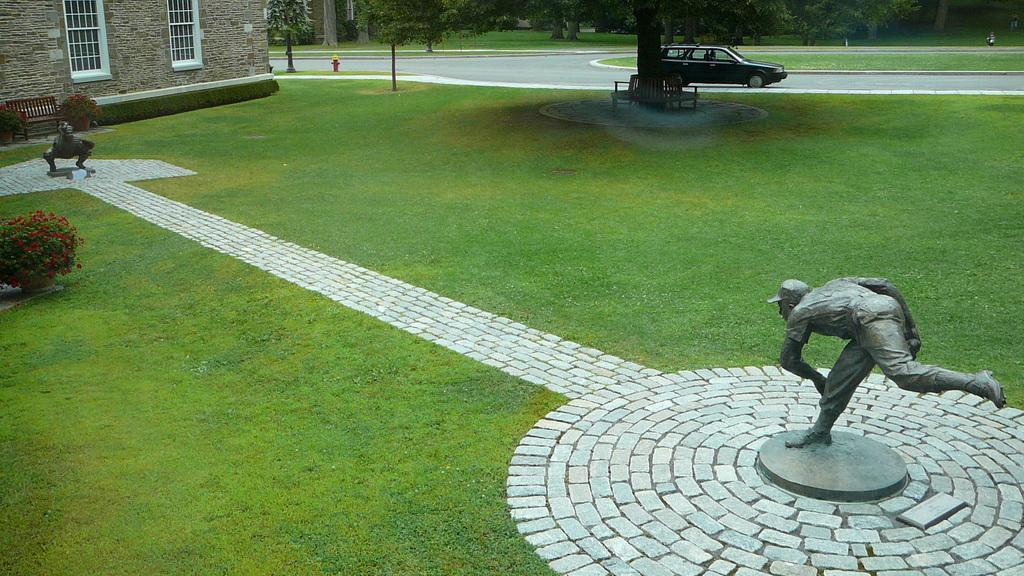In one or two sentences, can you explain what this image depicts? In this picture I can see sculptures, there is a vehicle on the road, there are benches, plants and trees, there is a wall with windows and there is a fire hydrant. 